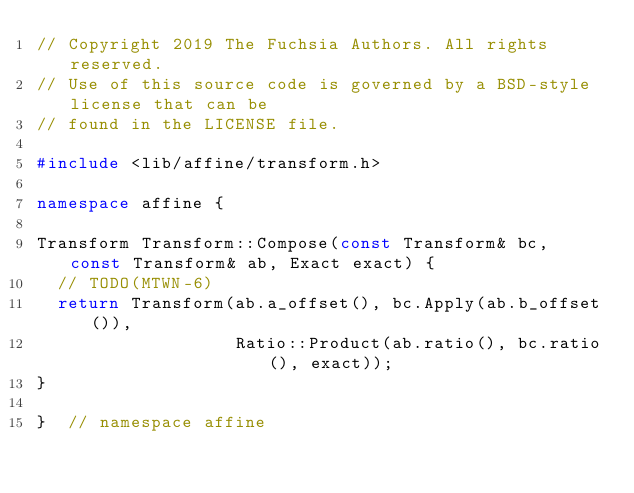Convert code to text. <code><loc_0><loc_0><loc_500><loc_500><_C++_>// Copyright 2019 The Fuchsia Authors. All rights reserved.
// Use of this source code is governed by a BSD-style license that can be
// found in the LICENSE file.

#include <lib/affine/transform.h>

namespace affine {

Transform Transform::Compose(const Transform& bc, const Transform& ab, Exact exact) {
  // TODO(MTWN-6)
  return Transform(ab.a_offset(), bc.Apply(ab.b_offset()),
                   Ratio::Product(ab.ratio(), bc.ratio(), exact));
}

}  // namespace affine
</code> 